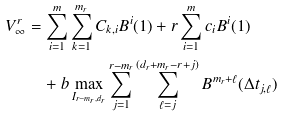Convert formula to latex. <formula><loc_0><loc_0><loc_500><loc_500>V ^ { r } _ { \infty } & = \sum _ { i = 1 } ^ { m } \sum _ { k = 1 } ^ { m _ { r } } C _ { k , i } B ^ { i } ( 1 ) + r \sum _ { i = 1 } ^ { m } c _ { i } B ^ { i } ( 1 ) \\ & \quad + b \max _ { I _ { r - m _ { r } , d _ { r } } } \sum _ { j = 1 } ^ { r - m _ { r } } \sum _ { \ell = j } ^ { ( d _ { r } + m _ { r } - r + j ) } B ^ { m _ { r } + \ell } ( \Delta t _ { j , \ell } )</formula> 